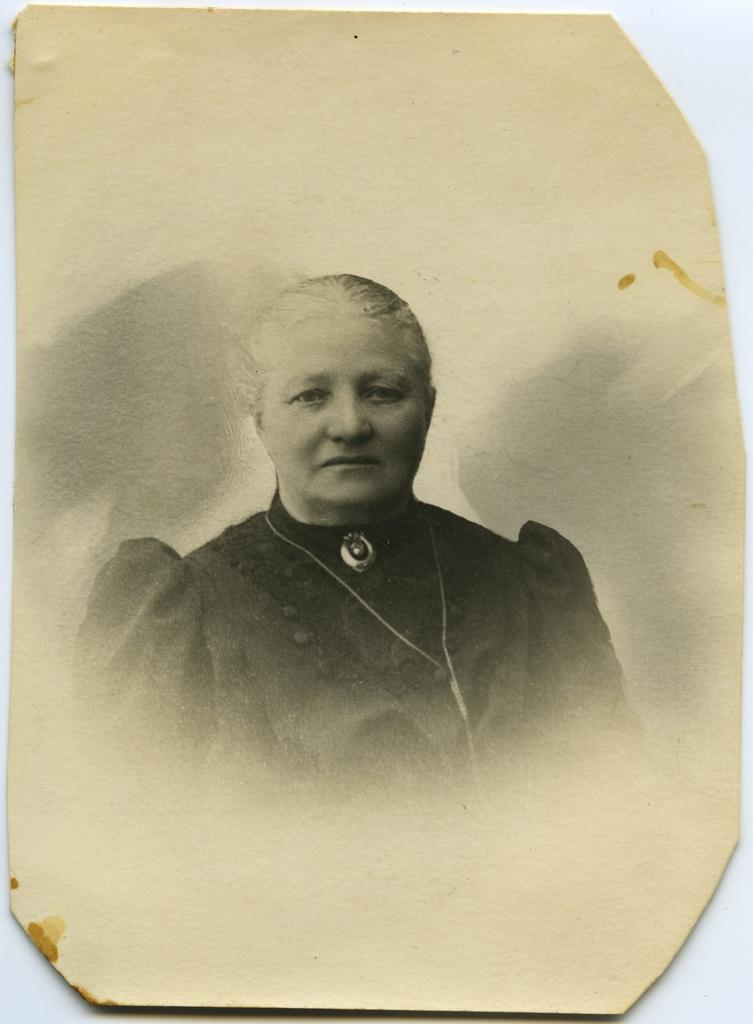What is the main object in the image? There is a cardboard sheet in the image. What is depicted on the cardboard sheet? There is an old picture of a woman on the cardboard sheet. What is the cardboard sheet placed on? The cardboard sheet is on a white object. What type of crib is visible in the image? There is no crib present in the image. How many heads are visible in the image? There is only one head visible in the image, which is the woman's head in the old picture. 